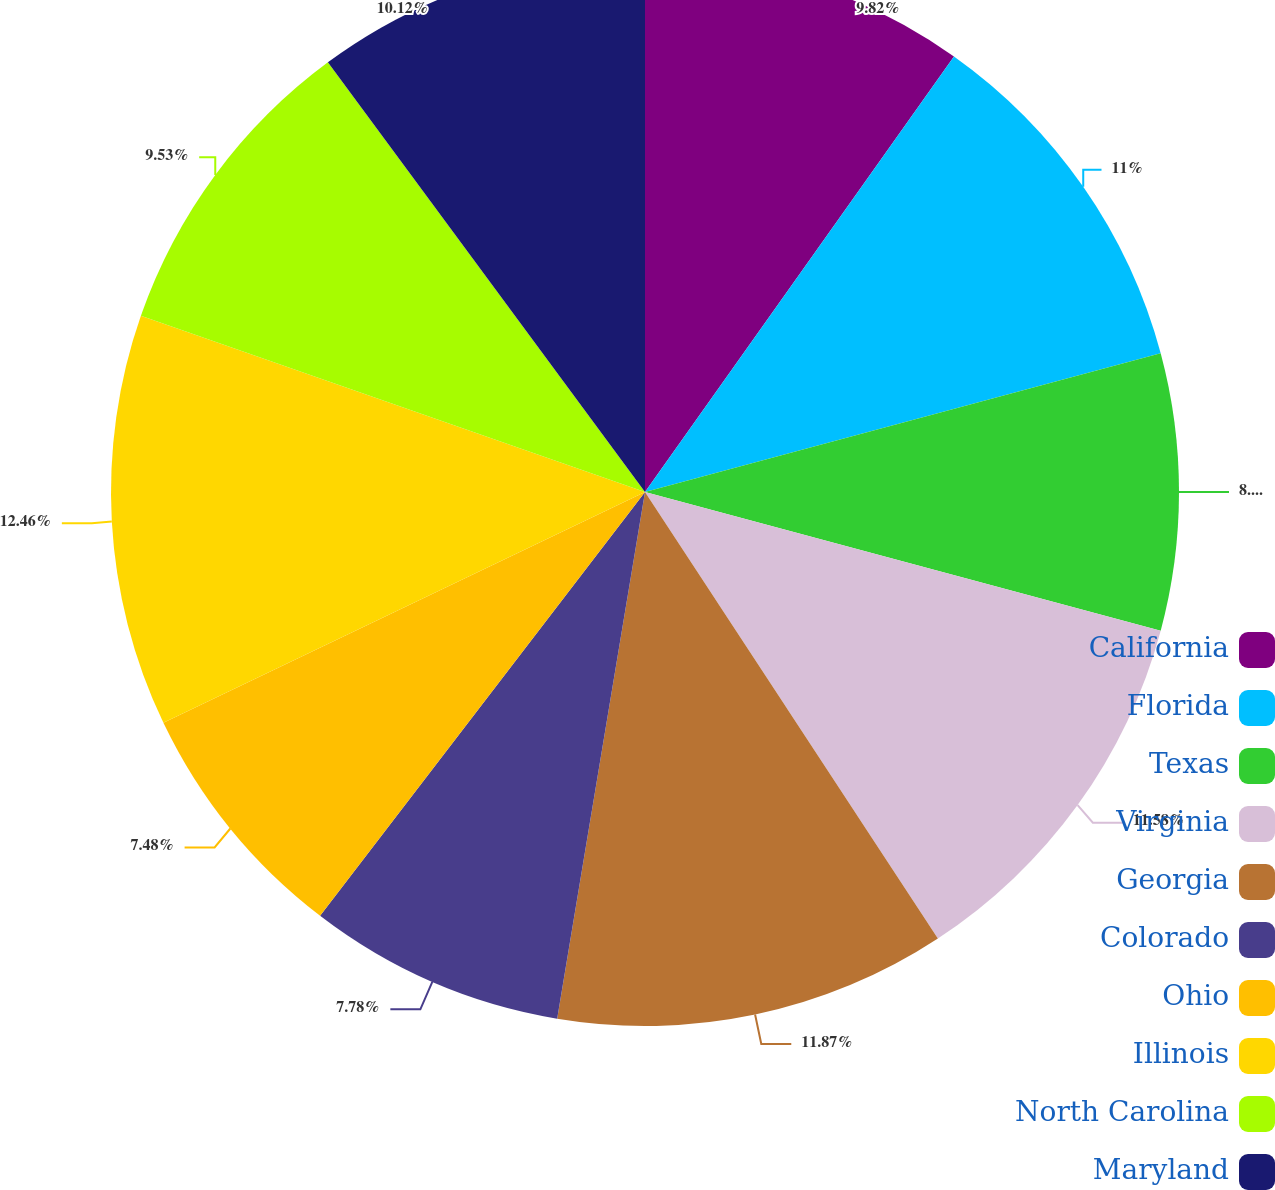Convert chart to OTSL. <chart><loc_0><loc_0><loc_500><loc_500><pie_chart><fcel>California<fcel>Florida<fcel>Texas<fcel>Virginia<fcel>Georgia<fcel>Colorado<fcel>Ohio<fcel>Illinois<fcel>North Carolina<fcel>Maryland<nl><fcel>9.82%<fcel>11.0%<fcel>8.36%<fcel>11.58%<fcel>11.87%<fcel>7.78%<fcel>7.48%<fcel>12.46%<fcel>9.53%<fcel>10.12%<nl></chart> 